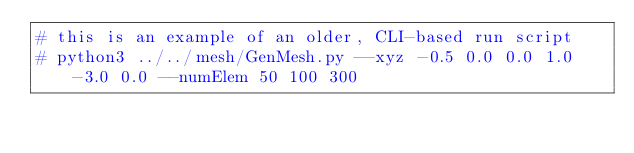<code> <loc_0><loc_0><loc_500><loc_500><_Bash_># this is an example of an older, CLI-based run script
# python3 ../../mesh/GenMesh.py --xyz -0.5 0.0 0.0 1.0 -3.0 0.0 --numElem 50 100 300</code> 